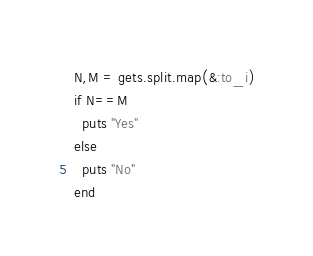Convert code to text. <code><loc_0><loc_0><loc_500><loc_500><_Ruby_>N,M = gets.split.map(&:to_i)
if N==M
  puts "Yes"
else
  puts "No"
end
</code> 